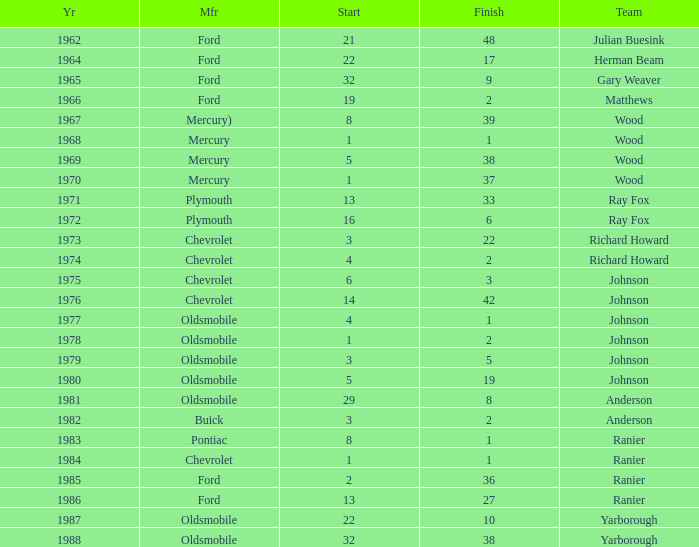What is the smallest finish time for a race where start was less than 3, buick was the manufacturer, and the race was held after 1978? None. 